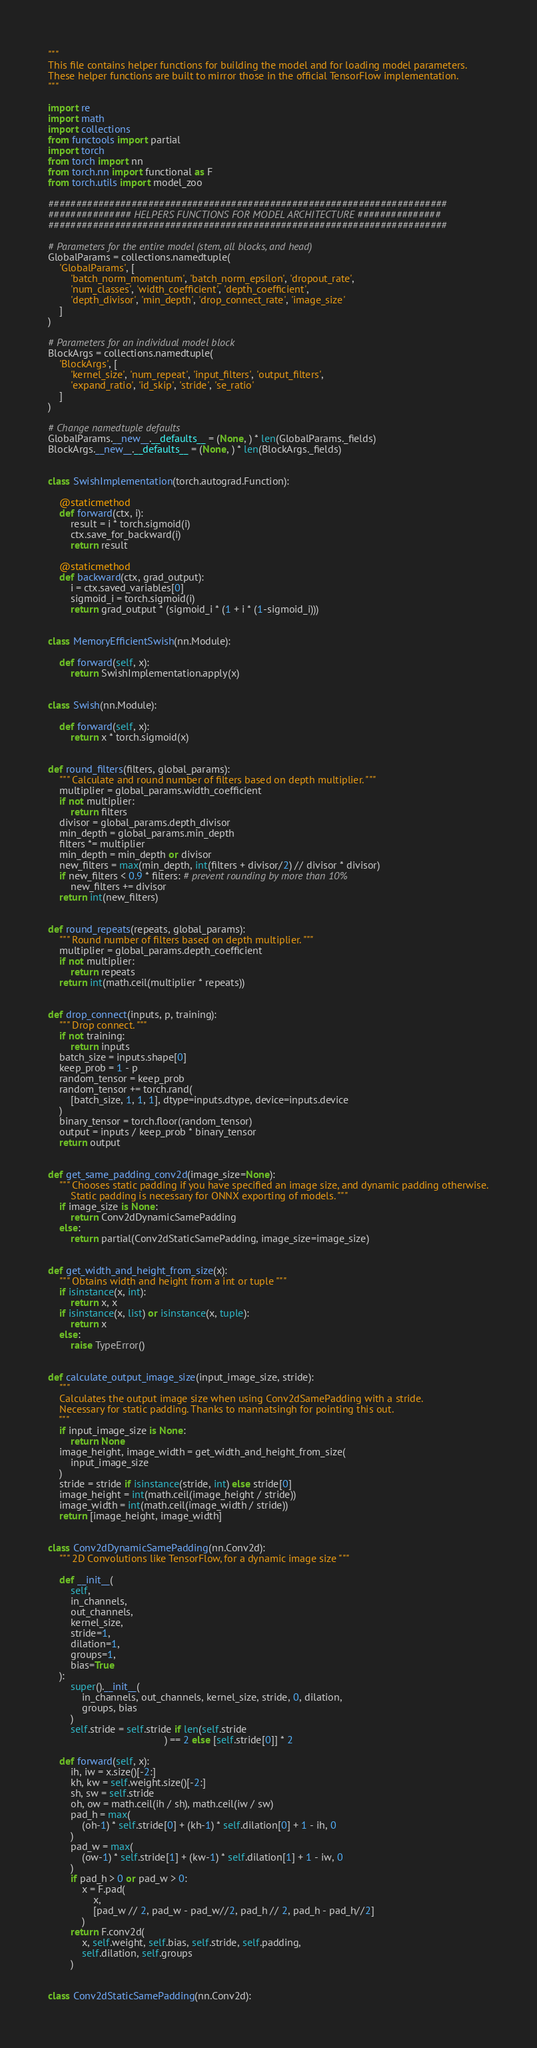<code> <loc_0><loc_0><loc_500><loc_500><_Python_>"""
This file contains helper functions for building the model and for loading model parameters.
These helper functions are built to mirror those in the official TensorFlow implementation.
"""

import re
import math
import collections
from functools import partial
import torch
from torch import nn
from torch.nn import functional as F
from torch.utils import model_zoo

########################################################################
############### HELPERS FUNCTIONS FOR MODEL ARCHITECTURE ###############
########################################################################

# Parameters for the entire model (stem, all blocks, and head)
GlobalParams = collections.namedtuple(
    'GlobalParams', [
        'batch_norm_momentum', 'batch_norm_epsilon', 'dropout_rate',
        'num_classes', 'width_coefficient', 'depth_coefficient',
        'depth_divisor', 'min_depth', 'drop_connect_rate', 'image_size'
    ]
)

# Parameters for an individual model block
BlockArgs = collections.namedtuple(
    'BlockArgs', [
        'kernel_size', 'num_repeat', 'input_filters', 'output_filters',
        'expand_ratio', 'id_skip', 'stride', 'se_ratio'
    ]
)

# Change namedtuple defaults
GlobalParams.__new__.__defaults__ = (None, ) * len(GlobalParams._fields)
BlockArgs.__new__.__defaults__ = (None, ) * len(BlockArgs._fields)


class SwishImplementation(torch.autograd.Function):

    @staticmethod
    def forward(ctx, i):
        result = i * torch.sigmoid(i)
        ctx.save_for_backward(i)
        return result

    @staticmethod
    def backward(ctx, grad_output):
        i = ctx.saved_variables[0]
        sigmoid_i = torch.sigmoid(i)
        return grad_output * (sigmoid_i * (1 + i * (1-sigmoid_i)))


class MemoryEfficientSwish(nn.Module):

    def forward(self, x):
        return SwishImplementation.apply(x)


class Swish(nn.Module):

    def forward(self, x):
        return x * torch.sigmoid(x)


def round_filters(filters, global_params):
    """ Calculate and round number of filters based on depth multiplier. """
    multiplier = global_params.width_coefficient
    if not multiplier:
        return filters
    divisor = global_params.depth_divisor
    min_depth = global_params.min_depth
    filters *= multiplier
    min_depth = min_depth or divisor
    new_filters = max(min_depth, int(filters + divisor/2) // divisor * divisor)
    if new_filters < 0.9 * filters: # prevent rounding by more than 10%
        new_filters += divisor
    return int(new_filters)


def round_repeats(repeats, global_params):
    """ Round number of filters based on depth multiplier. """
    multiplier = global_params.depth_coefficient
    if not multiplier:
        return repeats
    return int(math.ceil(multiplier * repeats))


def drop_connect(inputs, p, training):
    """ Drop connect. """
    if not training:
        return inputs
    batch_size = inputs.shape[0]
    keep_prob = 1 - p
    random_tensor = keep_prob
    random_tensor += torch.rand(
        [batch_size, 1, 1, 1], dtype=inputs.dtype, device=inputs.device
    )
    binary_tensor = torch.floor(random_tensor)
    output = inputs / keep_prob * binary_tensor
    return output


def get_same_padding_conv2d(image_size=None):
    """ Chooses static padding if you have specified an image size, and dynamic padding otherwise.
        Static padding is necessary for ONNX exporting of models. """
    if image_size is None:
        return Conv2dDynamicSamePadding
    else:
        return partial(Conv2dStaticSamePadding, image_size=image_size)


def get_width_and_height_from_size(x):
    """ Obtains width and height from a int or tuple """
    if isinstance(x, int):
        return x, x
    if isinstance(x, list) or isinstance(x, tuple):
        return x
    else:
        raise TypeError()


def calculate_output_image_size(input_image_size, stride):
    """
    Calculates the output image size when using Conv2dSamePadding with a stride.
    Necessary for static padding. Thanks to mannatsingh for pointing this out.
    """
    if input_image_size is None:
        return None
    image_height, image_width = get_width_and_height_from_size(
        input_image_size
    )
    stride = stride if isinstance(stride, int) else stride[0]
    image_height = int(math.ceil(image_height / stride))
    image_width = int(math.ceil(image_width / stride))
    return [image_height, image_width]


class Conv2dDynamicSamePadding(nn.Conv2d):
    """ 2D Convolutions like TensorFlow, for a dynamic image size """

    def __init__(
        self,
        in_channels,
        out_channels,
        kernel_size,
        stride=1,
        dilation=1,
        groups=1,
        bias=True
    ):
        super().__init__(
            in_channels, out_channels, kernel_size, stride, 0, dilation,
            groups, bias
        )
        self.stride = self.stride if len(self.stride
                                         ) == 2 else [self.stride[0]] * 2

    def forward(self, x):
        ih, iw = x.size()[-2:]
        kh, kw = self.weight.size()[-2:]
        sh, sw = self.stride
        oh, ow = math.ceil(ih / sh), math.ceil(iw / sw)
        pad_h = max(
            (oh-1) * self.stride[0] + (kh-1) * self.dilation[0] + 1 - ih, 0
        )
        pad_w = max(
            (ow-1) * self.stride[1] + (kw-1) * self.dilation[1] + 1 - iw, 0
        )
        if pad_h > 0 or pad_w > 0:
            x = F.pad(
                x,
                [pad_w // 2, pad_w - pad_w//2, pad_h // 2, pad_h - pad_h//2]
            )
        return F.conv2d(
            x, self.weight, self.bias, self.stride, self.padding,
            self.dilation, self.groups
        )


class Conv2dStaticSamePadding(nn.Conv2d):</code> 